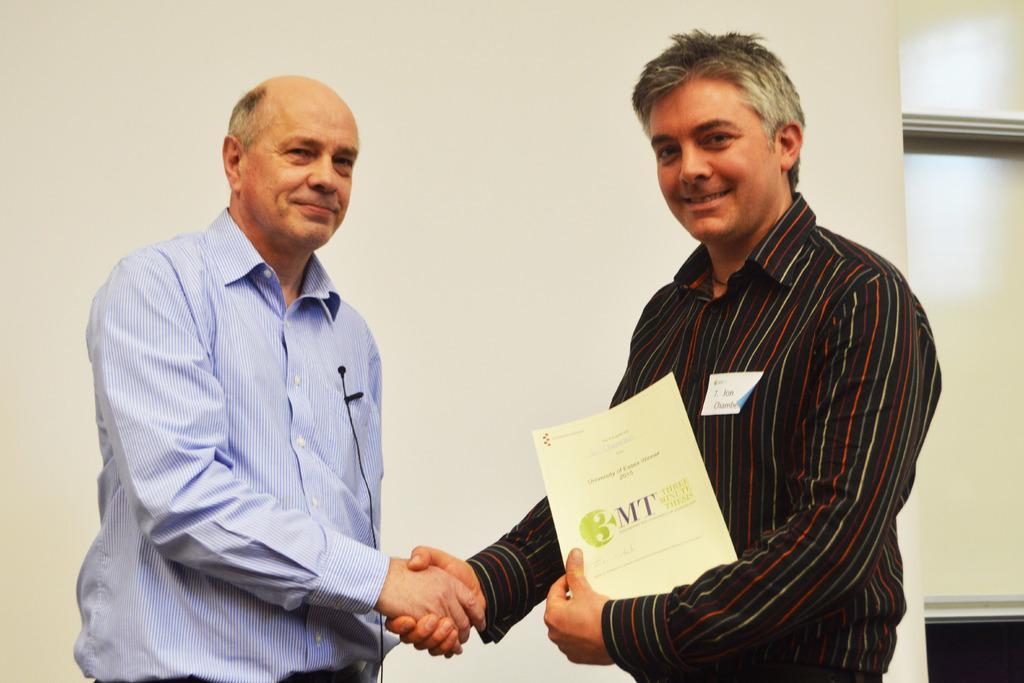Could you give a brief overview of what you see in this image? In the foreground of this image, there are two men shaking hands and a man is holding a paper. behind them, there is a wall. 